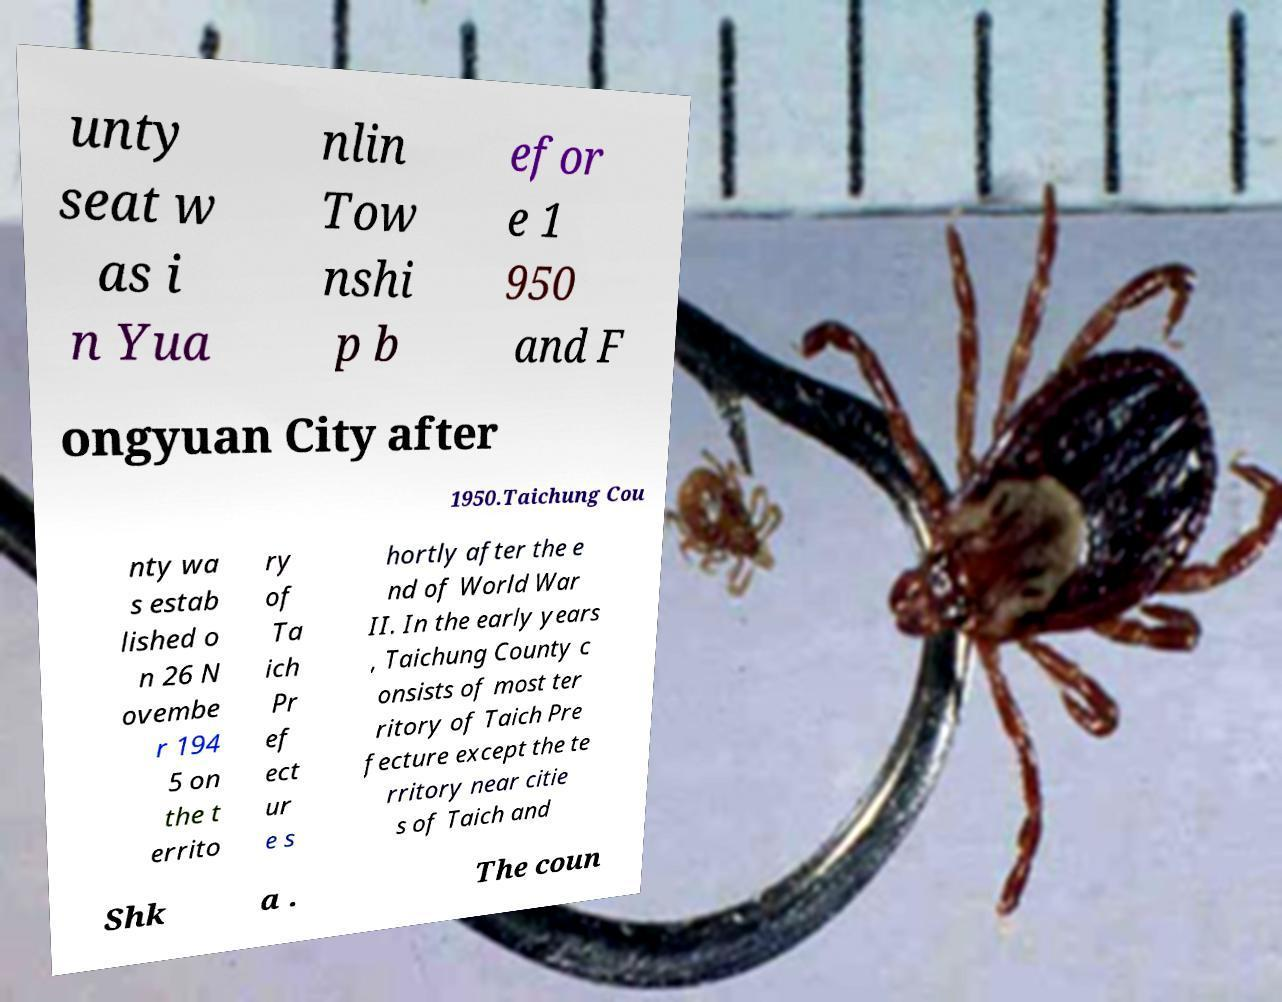What messages or text are displayed in this image? I need them in a readable, typed format. unty seat w as i n Yua nlin Tow nshi p b efor e 1 950 and F ongyuan City after 1950.Taichung Cou nty wa s estab lished o n 26 N ovembe r 194 5 on the t errito ry of Ta ich Pr ef ect ur e s hortly after the e nd of World War II. In the early years , Taichung County c onsists of most ter ritory of Taich Pre fecture except the te rritory near citie s of Taich and Shk a . The coun 